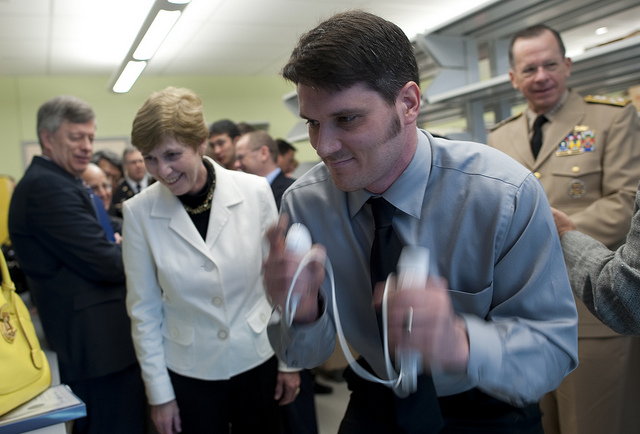What kind of setting do these people appear to be in? The individuals in the image appear to be in a professional or academic setting, likely involving research or technical work, as suggested by the uniform attire and the focused attention on the items at the desk. 